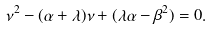<formula> <loc_0><loc_0><loc_500><loc_500>\nu ^ { 2 } - ( \alpha + \lambda ) \nu + ( \lambda \alpha - \beta ^ { 2 } ) = 0 .</formula> 